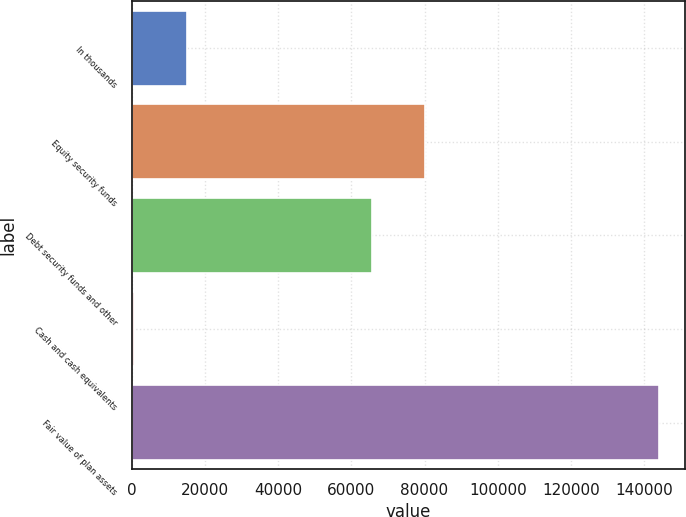Convert chart. <chart><loc_0><loc_0><loc_500><loc_500><bar_chart><fcel>In thousands<fcel>Equity security funds<fcel>Debt security funds and other<fcel>Cash and cash equivalents<fcel>Fair value of plan assets<nl><fcel>15038.9<fcel>80012.9<fcel>65674<fcel>700<fcel>144089<nl></chart> 